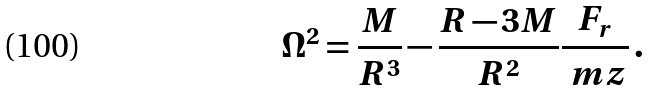<formula> <loc_0><loc_0><loc_500><loc_500>\Omega ^ { 2 } = \frac { M } { R ^ { 3 } } - \frac { R - 3 M } { R ^ { 2 } } \frac { F _ { r } } { \ m z } \, .</formula> 